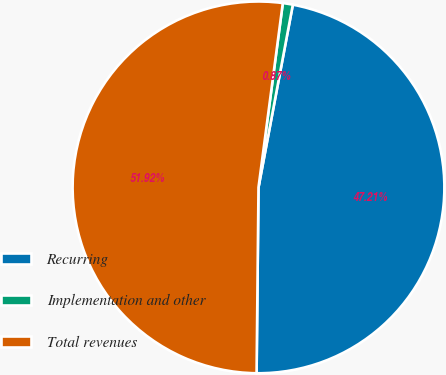Convert chart. <chart><loc_0><loc_0><loc_500><loc_500><pie_chart><fcel>Recurring<fcel>Implementation and other<fcel>Total revenues<nl><fcel>47.21%<fcel>0.87%<fcel>51.93%<nl></chart> 